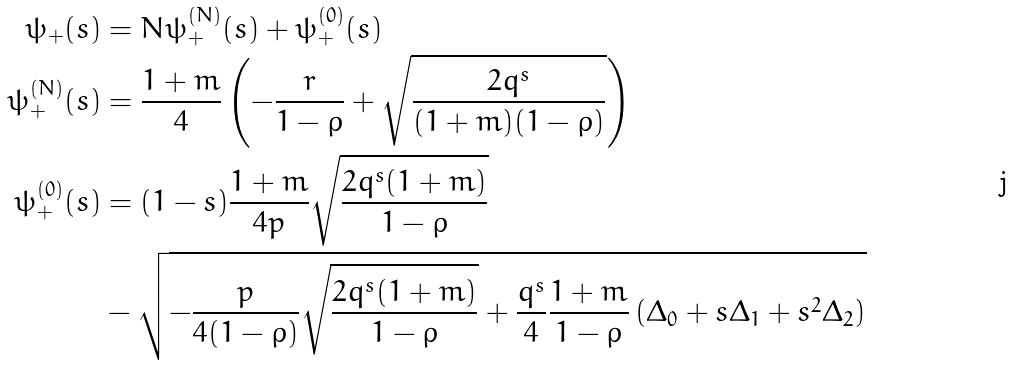<formula> <loc_0><loc_0><loc_500><loc_500>\psi _ { + } ( s ) & = N \psi _ { + } ^ { ( N ) } ( s ) + \psi _ { + } ^ { ( 0 ) } ( s ) \\ \psi _ { + } ^ { ( N ) } ( s ) & = \frac { 1 + m } { 4 } \left ( - \frac { r } { 1 - \rho } + \sqrt { \frac { 2 q ^ { s } } { ( 1 + m ) ( 1 - \rho ) } } \right ) \\ \psi _ { + } ^ { ( 0 ) } ( s ) & = ( 1 - s ) \frac { 1 + m } { 4 p } \sqrt { \frac { 2 q ^ { s } ( 1 + m ) } { 1 - \rho } } \\ & - \sqrt { - \frac { p } { 4 ( 1 - \rho ) } \sqrt { \frac { 2 q ^ { s } ( 1 + m ) } { 1 - \rho } } + \frac { q ^ { s } } { 4 } \frac { 1 + m } { 1 - \rho } \left ( \Delta _ { 0 } + s \Delta _ { 1 } + s ^ { 2 } \Delta _ { 2 } \right ) }</formula> 